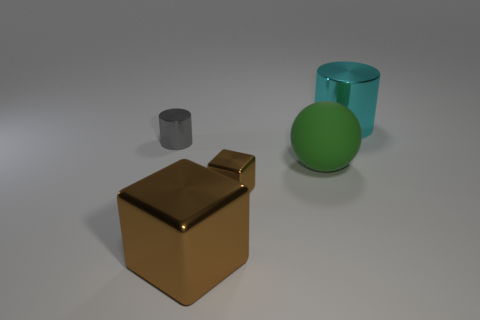What objects are shown in the image? The image displays four objects: a golden cube, a gray cylinder, a green sphere, and a teal cylinder. 